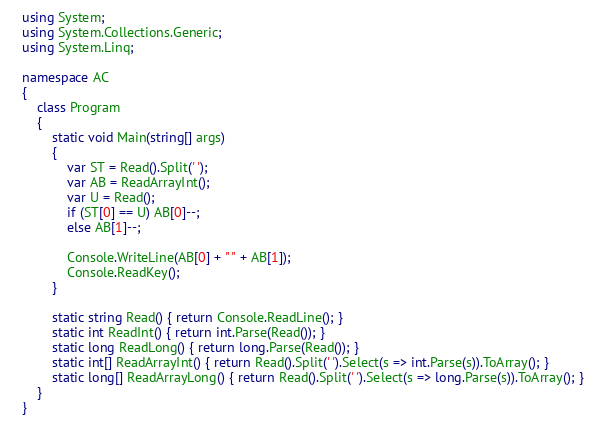Convert code to text. <code><loc_0><loc_0><loc_500><loc_500><_C#_>using System;
using System.Collections.Generic;
using System.Linq;

namespace AC
{
    class Program
    {
        static void Main(string[] args)
        {
            var ST = Read().Split(' ');
            var AB = ReadArrayInt();
            var U = Read();
            if (ST[0] == U) AB[0]--;
            else AB[1]--;

            Console.WriteLine(AB[0] + " " + AB[1]);
            Console.ReadKey();
        }

        static string Read() { return Console.ReadLine(); }
        static int ReadInt() { return int.Parse(Read()); }
        static long ReadLong() { return long.Parse(Read()); }
        static int[] ReadArrayInt() { return Read().Split(' ').Select(s => int.Parse(s)).ToArray(); }
        static long[] ReadArrayLong() { return Read().Split(' ').Select(s => long.Parse(s)).ToArray(); }
    }
}</code> 